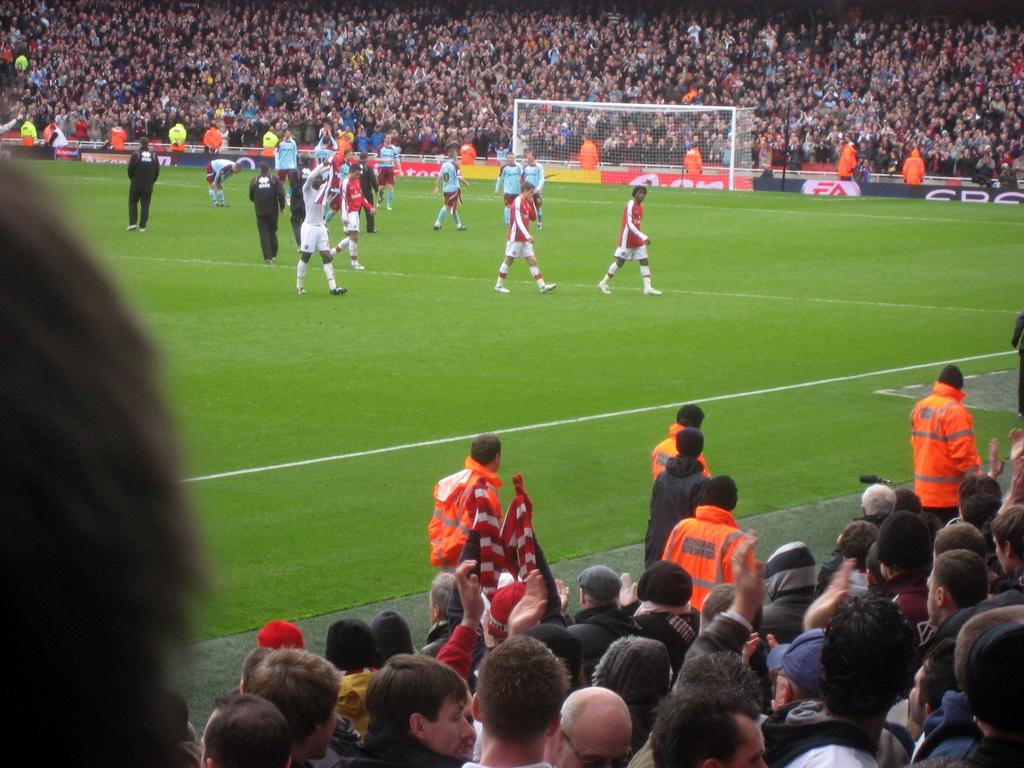What is the main subject of the image? The main subject of the image is a group of people on the ground. What else can be seen in the image besides the group of people? There are hoardings and a mesh visible in the image. Can you describe the background of the image? There is a crowd visible in the background of the image. What type of fruit is being used to cover the mesh in the image? There is no fruit present in the image, and the mesh is not covered by any fruit. 